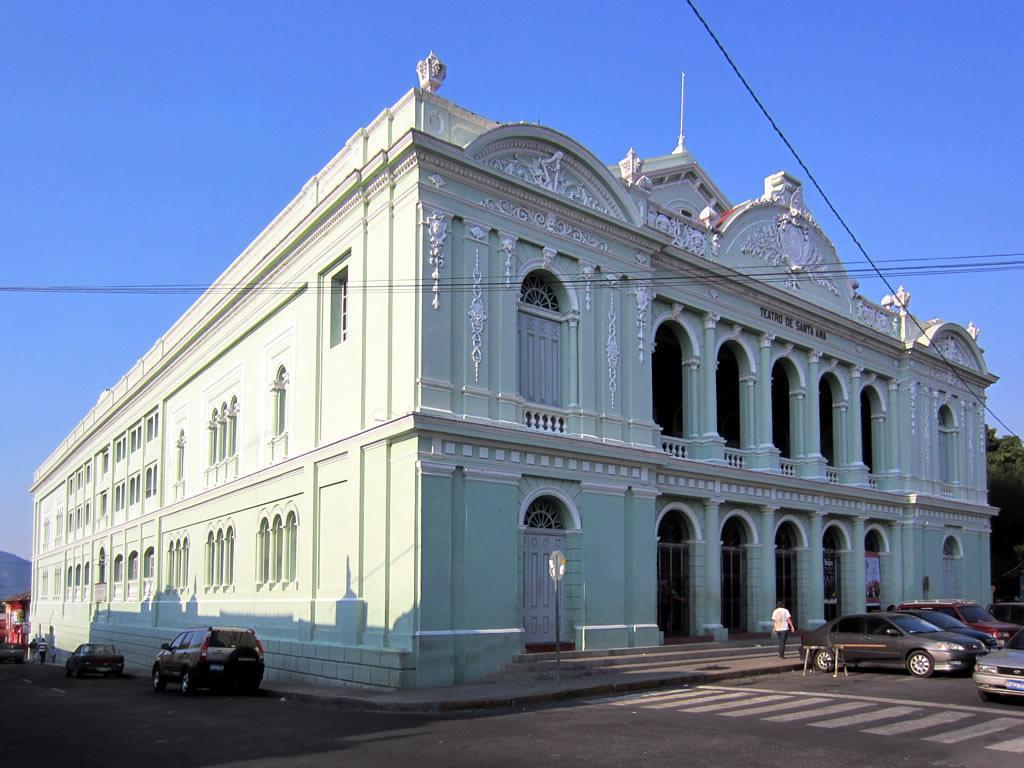How would you summarize this image in a sentence or two? In the image in the center, we can see a few vehicles on the road. And we can see one person walking on the staircase. In the background, we can see the sky, buildings, wires, pillars, doors, windows etc. 